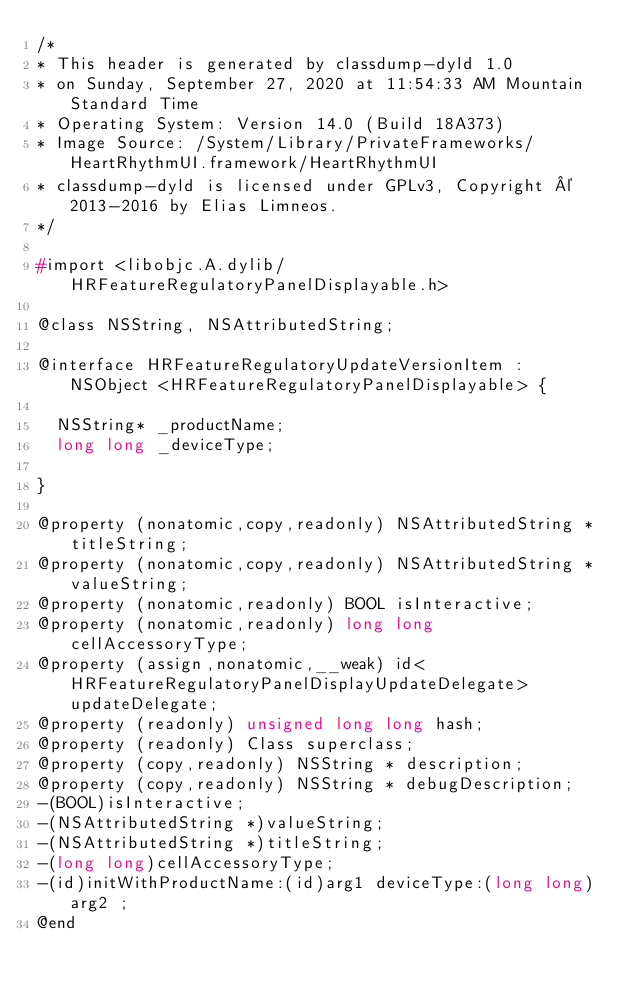<code> <loc_0><loc_0><loc_500><loc_500><_C_>/*
* This header is generated by classdump-dyld 1.0
* on Sunday, September 27, 2020 at 11:54:33 AM Mountain Standard Time
* Operating System: Version 14.0 (Build 18A373)
* Image Source: /System/Library/PrivateFrameworks/HeartRhythmUI.framework/HeartRhythmUI
* classdump-dyld is licensed under GPLv3, Copyright © 2013-2016 by Elias Limneos.
*/

#import <libobjc.A.dylib/HRFeatureRegulatoryPanelDisplayable.h>

@class NSString, NSAttributedString;

@interface HRFeatureRegulatoryUpdateVersionItem : NSObject <HRFeatureRegulatoryPanelDisplayable> {

	NSString* _productName;
	long long _deviceType;

}

@property (nonatomic,copy,readonly) NSAttributedString * titleString; 
@property (nonatomic,copy,readonly) NSAttributedString * valueString; 
@property (nonatomic,readonly) BOOL isInteractive; 
@property (nonatomic,readonly) long long cellAccessoryType; 
@property (assign,nonatomic,__weak) id<HRFeatureRegulatoryPanelDisplayUpdateDelegate> updateDelegate; 
@property (readonly) unsigned long long hash; 
@property (readonly) Class superclass; 
@property (copy,readonly) NSString * description; 
@property (copy,readonly) NSString * debugDescription; 
-(BOOL)isInteractive;
-(NSAttributedString *)valueString;
-(NSAttributedString *)titleString;
-(long long)cellAccessoryType;
-(id)initWithProductName:(id)arg1 deviceType:(long long)arg2 ;
@end

</code> 